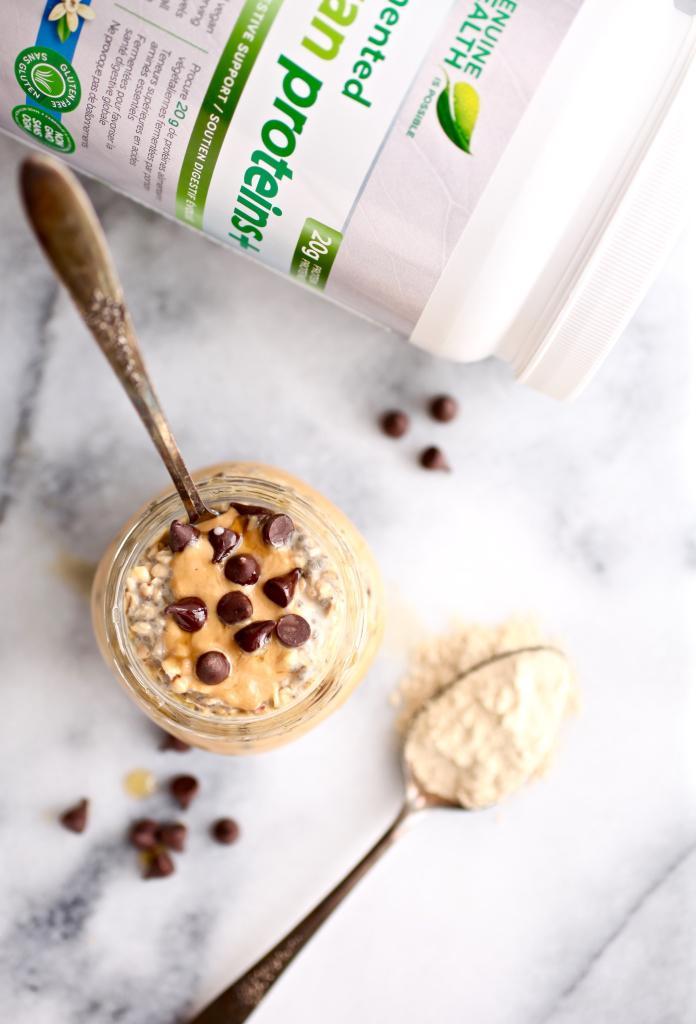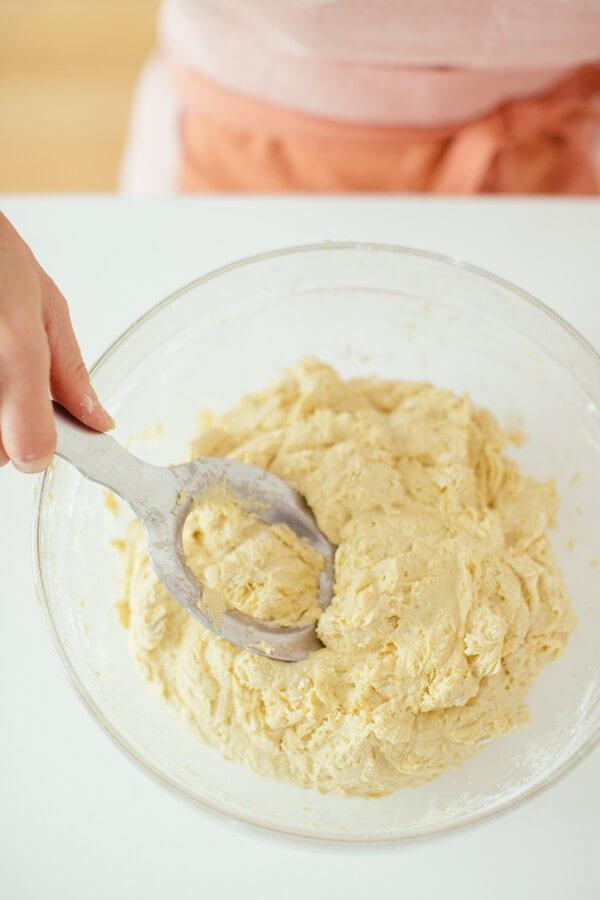The first image is the image on the left, the second image is the image on the right. Assess this claim about the two images: "There is at least one human hand holding a spoon.". Correct or not? Answer yes or no. Yes. 